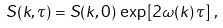Convert formula to latex. <formula><loc_0><loc_0><loc_500><loc_500>S ( k , \tau ) = S ( k , 0 ) \, \exp \left [ 2 \omega ( k ) \, \tau \right ] \, ,</formula> 